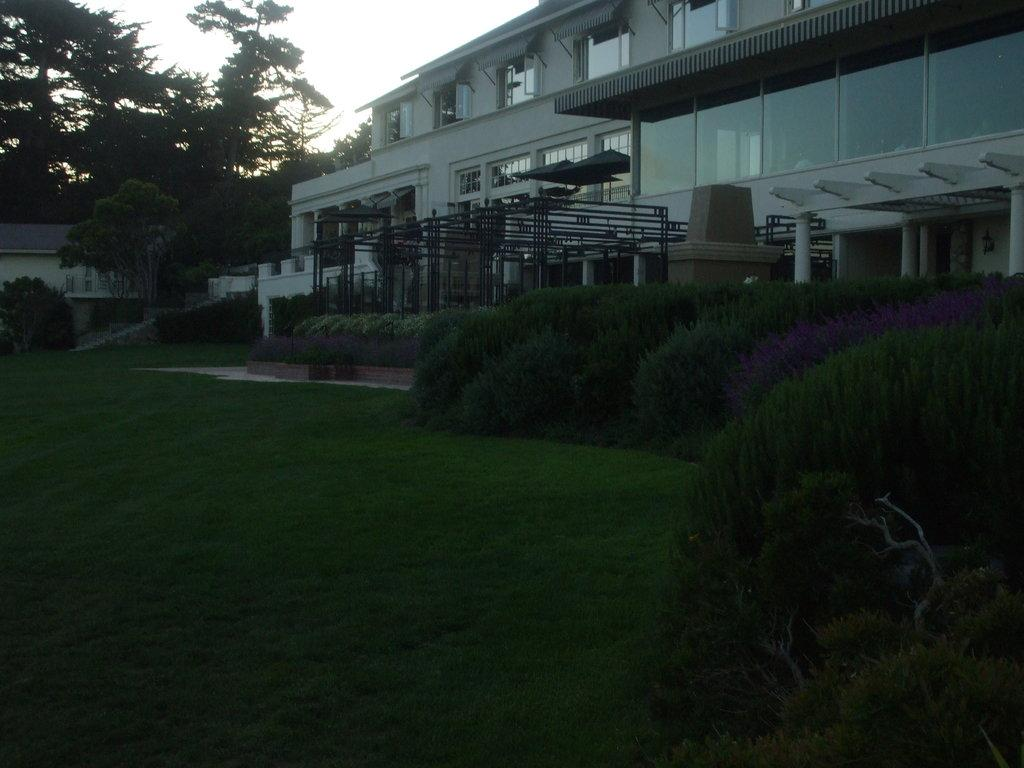What type of structures can be seen in the image? There are buildings with windows in the image. What are the vertical objects in the image? There are poles in the image. What type of vegetation is present in the image? There are plants, trees, and grass in the image. What can be seen in the background of the image? The sky is visible in the background of the image. What position does the brick hold in the image? There is no brick present in the image. What type of box can be seen in the image? There is no box present in the image. 